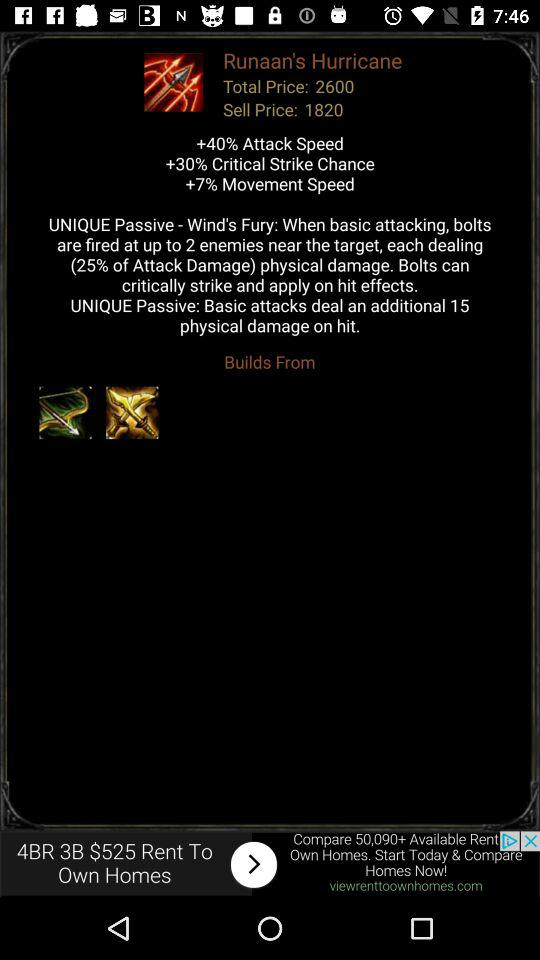What is the sell price? The sell price is 1820. 